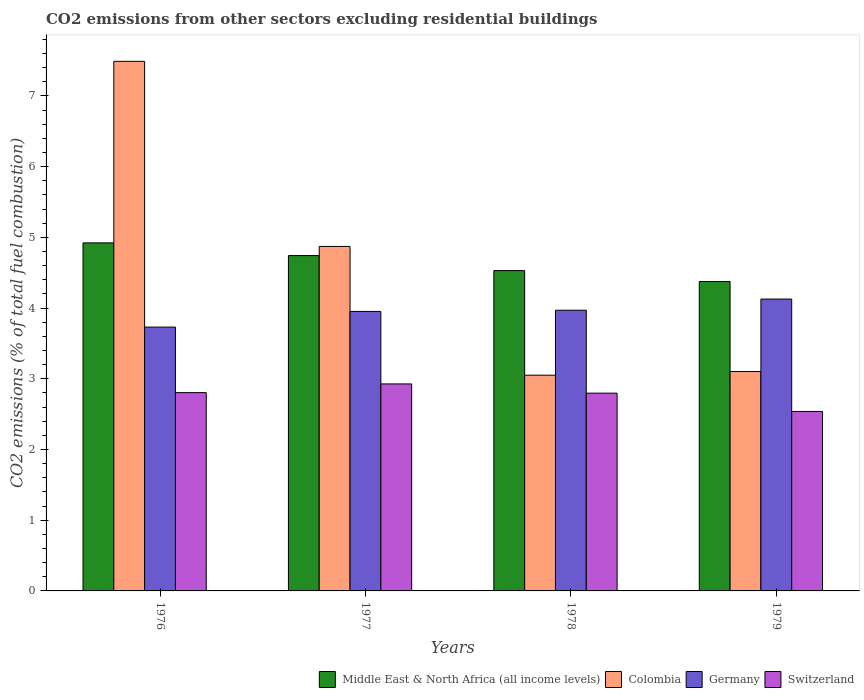How many different coloured bars are there?
Keep it short and to the point. 4. Are the number of bars on each tick of the X-axis equal?
Provide a succinct answer. Yes. How many bars are there on the 3rd tick from the right?
Offer a very short reply. 4. What is the label of the 3rd group of bars from the left?
Provide a succinct answer. 1978. In how many cases, is the number of bars for a given year not equal to the number of legend labels?
Offer a terse response. 0. What is the total CO2 emitted in Switzerland in 1978?
Your answer should be compact. 2.8. Across all years, what is the maximum total CO2 emitted in Middle East & North Africa (all income levels)?
Make the answer very short. 4.92. Across all years, what is the minimum total CO2 emitted in Switzerland?
Offer a terse response. 2.54. In which year was the total CO2 emitted in Colombia maximum?
Provide a succinct answer. 1976. In which year was the total CO2 emitted in Switzerland minimum?
Provide a succinct answer. 1979. What is the total total CO2 emitted in Colombia in the graph?
Ensure brevity in your answer.  18.52. What is the difference between the total CO2 emitted in Switzerland in 1976 and that in 1979?
Your response must be concise. 0.27. What is the difference between the total CO2 emitted in Colombia in 1976 and the total CO2 emitted in Germany in 1979?
Offer a terse response. 3.36. What is the average total CO2 emitted in Colombia per year?
Offer a terse response. 4.63. In the year 1979, what is the difference between the total CO2 emitted in Colombia and total CO2 emitted in Middle East & North Africa (all income levels)?
Keep it short and to the point. -1.27. What is the ratio of the total CO2 emitted in Germany in 1976 to that in 1979?
Your response must be concise. 0.9. Is the total CO2 emitted in Colombia in 1976 less than that in 1978?
Make the answer very short. No. What is the difference between the highest and the second highest total CO2 emitted in Germany?
Give a very brief answer. 0.16. What is the difference between the highest and the lowest total CO2 emitted in Colombia?
Your answer should be very brief. 4.44. In how many years, is the total CO2 emitted in Switzerland greater than the average total CO2 emitted in Switzerland taken over all years?
Provide a succinct answer. 3. Is the sum of the total CO2 emitted in Middle East & North Africa (all income levels) in 1977 and 1978 greater than the maximum total CO2 emitted in Colombia across all years?
Offer a terse response. Yes. What does the 2nd bar from the left in 1976 represents?
Your answer should be very brief. Colombia. What does the 1st bar from the right in 1976 represents?
Your response must be concise. Switzerland. Is it the case that in every year, the sum of the total CO2 emitted in Colombia and total CO2 emitted in Germany is greater than the total CO2 emitted in Middle East & North Africa (all income levels)?
Give a very brief answer. Yes. How many bars are there?
Offer a very short reply. 16. Are all the bars in the graph horizontal?
Offer a very short reply. No. How many years are there in the graph?
Give a very brief answer. 4. What is the difference between two consecutive major ticks on the Y-axis?
Your response must be concise. 1. Are the values on the major ticks of Y-axis written in scientific E-notation?
Your response must be concise. No. Where does the legend appear in the graph?
Make the answer very short. Bottom right. How many legend labels are there?
Make the answer very short. 4. What is the title of the graph?
Your answer should be compact. CO2 emissions from other sectors excluding residential buildings. What is the label or title of the Y-axis?
Make the answer very short. CO2 emissions (% of total fuel combustion). What is the CO2 emissions (% of total fuel combustion) in Middle East & North Africa (all income levels) in 1976?
Your answer should be very brief. 4.92. What is the CO2 emissions (% of total fuel combustion) of Colombia in 1976?
Keep it short and to the point. 7.49. What is the CO2 emissions (% of total fuel combustion) of Germany in 1976?
Your answer should be very brief. 3.73. What is the CO2 emissions (% of total fuel combustion) of Switzerland in 1976?
Provide a short and direct response. 2.8. What is the CO2 emissions (% of total fuel combustion) in Middle East & North Africa (all income levels) in 1977?
Your answer should be very brief. 4.74. What is the CO2 emissions (% of total fuel combustion) of Colombia in 1977?
Your answer should be very brief. 4.87. What is the CO2 emissions (% of total fuel combustion) in Germany in 1977?
Keep it short and to the point. 3.95. What is the CO2 emissions (% of total fuel combustion) in Switzerland in 1977?
Your response must be concise. 2.93. What is the CO2 emissions (% of total fuel combustion) in Middle East & North Africa (all income levels) in 1978?
Your answer should be compact. 4.53. What is the CO2 emissions (% of total fuel combustion) in Colombia in 1978?
Your response must be concise. 3.05. What is the CO2 emissions (% of total fuel combustion) in Germany in 1978?
Offer a very short reply. 3.97. What is the CO2 emissions (% of total fuel combustion) of Switzerland in 1978?
Keep it short and to the point. 2.8. What is the CO2 emissions (% of total fuel combustion) in Middle East & North Africa (all income levels) in 1979?
Make the answer very short. 4.38. What is the CO2 emissions (% of total fuel combustion) of Colombia in 1979?
Make the answer very short. 3.1. What is the CO2 emissions (% of total fuel combustion) of Germany in 1979?
Make the answer very short. 4.13. What is the CO2 emissions (% of total fuel combustion) in Switzerland in 1979?
Keep it short and to the point. 2.54. Across all years, what is the maximum CO2 emissions (% of total fuel combustion) in Middle East & North Africa (all income levels)?
Provide a short and direct response. 4.92. Across all years, what is the maximum CO2 emissions (% of total fuel combustion) of Colombia?
Your answer should be compact. 7.49. Across all years, what is the maximum CO2 emissions (% of total fuel combustion) of Germany?
Make the answer very short. 4.13. Across all years, what is the maximum CO2 emissions (% of total fuel combustion) in Switzerland?
Keep it short and to the point. 2.93. Across all years, what is the minimum CO2 emissions (% of total fuel combustion) of Middle East & North Africa (all income levels)?
Offer a very short reply. 4.38. Across all years, what is the minimum CO2 emissions (% of total fuel combustion) in Colombia?
Make the answer very short. 3.05. Across all years, what is the minimum CO2 emissions (% of total fuel combustion) of Germany?
Offer a very short reply. 3.73. Across all years, what is the minimum CO2 emissions (% of total fuel combustion) of Switzerland?
Make the answer very short. 2.54. What is the total CO2 emissions (% of total fuel combustion) in Middle East & North Africa (all income levels) in the graph?
Ensure brevity in your answer.  18.57. What is the total CO2 emissions (% of total fuel combustion) in Colombia in the graph?
Make the answer very short. 18.52. What is the total CO2 emissions (% of total fuel combustion) of Germany in the graph?
Ensure brevity in your answer.  15.78. What is the total CO2 emissions (% of total fuel combustion) in Switzerland in the graph?
Your answer should be very brief. 11.07. What is the difference between the CO2 emissions (% of total fuel combustion) in Middle East & North Africa (all income levels) in 1976 and that in 1977?
Offer a terse response. 0.18. What is the difference between the CO2 emissions (% of total fuel combustion) of Colombia in 1976 and that in 1977?
Ensure brevity in your answer.  2.62. What is the difference between the CO2 emissions (% of total fuel combustion) in Germany in 1976 and that in 1977?
Offer a terse response. -0.22. What is the difference between the CO2 emissions (% of total fuel combustion) of Switzerland in 1976 and that in 1977?
Your answer should be very brief. -0.12. What is the difference between the CO2 emissions (% of total fuel combustion) in Middle East & North Africa (all income levels) in 1976 and that in 1978?
Give a very brief answer. 0.39. What is the difference between the CO2 emissions (% of total fuel combustion) in Colombia in 1976 and that in 1978?
Your answer should be compact. 4.44. What is the difference between the CO2 emissions (% of total fuel combustion) in Germany in 1976 and that in 1978?
Offer a very short reply. -0.24. What is the difference between the CO2 emissions (% of total fuel combustion) in Switzerland in 1976 and that in 1978?
Keep it short and to the point. 0.01. What is the difference between the CO2 emissions (% of total fuel combustion) in Middle East & North Africa (all income levels) in 1976 and that in 1979?
Give a very brief answer. 0.55. What is the difference between the CO2 emissions (% of total fuel combustion) of Colombia in 1976 and that in 1979?
Offer a terse response. 4.39. What is the difference between the CO2 emissions (% of total fuel combustion) in Germany in 1976 and that in 1979?
Keep it short and to the point. -0.4. What is the difference between the CO2 emissions (% of total fuel combustion) in Switzerland in 1976 and that in 1979?
Make the answer very short. 0.27. What is the difference between the CO2 emissions (% of total fuel combustion) in Middle East & North Africa (all income levels) in 1977 and that in 1978?
Give a very brief answer. 0.21. What is the difference between the CO2 emissions (% of total fuel combustion) in Colombia in 1977 and that in 1978?
Make the answer very short. 1.82. What is the difference between the CO2 emissions (% of total fuel combustion) in Germany in 1977 and that in 1978?
Provide a succinct answer. -0.02. What is the difference between the CO2 emissions (% of total fuel combustion) in Switzerland in 1977 and that in 1978?
Make the answer very short. 0.13. What is the difference between the CO2 emissions (% of total fuel combustion) of Middle East & North Africa (all income levels) in 1977 and that in 1979?
Keep it short and to the point. 0.37. What is the difference between the CO2 emissions (% of total fuel combustion) in Colombia in 1977 and that in 1979?
Provide a short and direct response. 1.77. What is the difference between the CO2 emissions (% of total fuel combustion) of Germany in 1977 and that in 1979?
Make the answer very short. -0.17. What is the difference between the CO2 emissions (% of total fuel combustion) of Switzerland in 1977 and that in 1979?
Keep it short and to the point. 0.39. What is the difference between the CO2 emissions (% of total fuel combustion) of Middle East & North Africa (all income levels) in 1978 and that in 1979?
Keep it short and to the point. 0.15. What is the difference between the CO2 emissions (% of total fuel combustion) in Colombia in 1978 and that in 1979?
Provide a succinct answer. -0.05. What is the difference between the CO2 emissions (% of total fuel combustion) in Germany in 1978 and that in 1979?
Give a very brief answer. -0.16. What is the difference between the CO2 emissions (% of total fuel combustion) in Switzerland in 1978 and that in 1979?
Keep it short and to the point. 0.26. What is the difference between the CO2 emissions (% of total fuel combustion) in Middle East & North Africa (all income levels) in 1976 and the CO2 emissions (% of total fuel combustion) in Colombia in 1977?
Ensure brevity in your answer.  0.05. What is the difference between the CO2 emissions (% of total fuel combustion) of Middle East & North Africa (all income levels) in 1976 and the CO2 emissions (% of total fuel combustion) of Germany in 1977?
Give a very brief answer. 0.97. What is the difference between the CO2 emissions (% of total fuel combustion) of Middle East & North Africa (all income levels) in 1976 and the CO2 emissions (% of total fuel combustion) of Switzerland in 1977?
Your answer should be very brief. 2. What is the difference between the CO2 emissions (% of total fuel combustion) of Colombia in 1976 and the CO2 emissions (% of total fuel combustion) of Germany in 1977?
Ensure brevity in your answer.  3.54. What is the difference between the CO2 emissions (% of total fuel combustion) in Colombia in 1976 and the CO2 emissions (% of total fuel combustion) in Switzerland in 1977?
Offer a very short reply. 4.56. What is the difference between the CO2 emissions (% of total fuel combustion) in Germany in 1976 and the CO2 emissions (% of total fuel combustion) in Switzerland in 1977?
Provide a succinct answer. 0.8. What is the difference between the CO2 emissions (% of total fuel combustion) of Middle East & North Africa (all income levels) in 1976 and the CO2 emissions (% of total fuel combustion) of Colombia in 1978?
Your answer should be compact. 1.87. What is the difference between the CO2 emissions (% of total fuel combustion) in Middle East & North Africa (all income levels) in 1976 and the CO2 emissions (% of total fuel combustion) in Germany in 1978?
Offer a very short reply. 0.95. What is the difference between the CO2 emissions (% of total fuel combustion) in Middle East & North Africa (all income levels) in 1976 and the CO2 emissions (% of total fuel combustion) in Switzerland in 1978?
Your answer should be compact. 2.13. What is the difference between the CO2 emissions (% of total fuel combustion) in Colombia in 1976 and the CO2 emissions (% of total fuel combustion) in Germany in 1978?
Keep it short and to the point. 3.52. What is the difference between the CO2 emissions (% of total fuel combustion) of Colombia in 1976 and the CO2 emissions (% of total fuel combustion) of Switzerland in 1978?
Provide a succinct answer. 4.69. What is the difference between the CO2 emissions (% of total fuel combustion) in Germany in 1976 and the CO2 emissions (% of total fuel combustion) in Switzerland in 1978?
Provide a short and direct response. 0.93. What is the difference between the CO2 emissions (% of total fuel combustion) in Middle East & North Africa (all income levels) in 1976 and the CO2 emissions (% of total fuel combustion) in Colombia in 1979?
Ensure brevity in your answer.  1.82. What is the difference between the CO2 emissions (% of total fuel combustion) in Middle East & North Africa (all income levels) in 1976 and the CO2 emissions (% of total fuel combustion) in Germany in 1979?
Provide a succinct answer. 0.79. What is the difference between the CO2 emissions (% of total fuel combustion) in Middle East & North Africa (all income levels) in 1976 and the CO2 emissions (% of total fuel combustion) in Switzerland in 1979?
Provide a short and direct response. 2.38. What is the difference between the CO2 emissions (% of total fuel combustion) of Colombia in 1976 and the CO2 emissions (% of total fuel combustion) of Germany in 1979?
Your answer should be compact. 3.36. What is the difference between the CO2 emissions (% of total fuel combustion) in Colombia in 1976 and the CO2 emissions (% of total fuel combustion) in Switzerland in 1979?
Your answer should be very brief. 4.95. What is the difference between the CO2 emissions (% of total fuel combustion) in Germany in 1976 and the CO2 emissions (% of total fuel combustion) in Switzerland in 1979?
Give a very brief answer. 1.19. What is the difference between the CO2 emissions (% of total fuel combustion) in Middle East & North Africa (all income levels) in 1977 and the CO2 emissions (% of total fuel combustion) in Colombia in 1978?
Offer a very short reply. 1.69. What is the difference between the CO2 emissions (% of total fuel combustion) in Middle East & North Africa (all income levels) in 1977 and the CO2 emissions (% of total fuel combustion) in Germany in 1978?
Your answer should be compact. 0.77. What is the difference between the CO2 emissions (% of total fuel combustion) of Middle East & North Africa (all income levels) in 1977 and the CO2 emissions (% of total fuel combustion) of Switzerland in 1978?
Keep it short and to the point. 1.95. What is the difference between the CO2 emissions (% of total fuel combustion) of Colombia in 1977 and the CO2 emissions (% of total fuel combustion) of Germany in 1978?
Your answer should be compact. 0.9. What is the difference between the CO2 emissions (% of total fuel combustion) in Colombia in 1977 and the CO2 emissions (% of total fuel combustion) in Switzerland in 1978?
Your response must be concise. 2.08. What is the difference between the CO2 emissions (% of total fuel combustion) in Germany in 1977 and the CO2 emissions (% of total fuel combustion) in Switzerland in 1978?
Your response must be concise. 1.16. What is the difference between the CO2 emissions (% of total fuel combustion) of Middle East & North Africa (all income levels) in 1977 and the CO2 emissions (% of total fuel combustion) of Colombia in 1979?
Make the answer very short. 1.64. What is the difference between the CO2 emissions (% of total fuel combustion) of Middle East & North Africa (all income levels) in 1977 and the CO2 emissions (% of total fuel combustion) of Germany in 1979?
Ensure brevity in your answer.  0.61. What is the difference between the CO2 emissions (% of total fuel combustion) of Middle East & North Africa (all income levels) in 1977 and the CO2 emissions (% of total fuel combustion) of Switzerland in 1979?
Keep it short and to the point. 2.2. What is the difference between the CO2 emissions (% of total fuel combustion) in Colombia in 1977 and the CO2 emissions (% of total fuel combustion) in Germany in 1979?
Make the answer very short. 0.74. What is the difference between the CO2 emissions (% of total fuel combustion) of Colombia in 1977 and the CO2 emissions (% of total fuel combustion) of Switzerland in 1979?
Provide a short and direct response. 2.33. What is the difference between the CO2 emissions (% of total fuel combustion) in Germany in 1977 and the CO2 emissions (% of total fuel combustion) in Switzerland in 1979?
Your answer should be compact. 1.41. What is the difference between the CO2 emissions (% of total fuel combustion) in Middle East & North Africa (all income levels) in 1978 and the CO2 emissions (% of total fuel combustion) in Colombia in 1979?
Your answer should be compact. 1.43. What is the difference between the CO2 emissions (% of total fuel combustion) of Middle East & North Africa (all income levels) in 1978 and the CO2 emissions (% of total fuel combustion) of Germany in 1979?
Your response must be concise. 0.4. What is the difference between the CO2 emissions (% of total fuel combustion) of Middle East & North Africa (all income levels) in 1978 and the CO2 emissions (% of total fuel combustion) of Switzerland in 1979?
Keep it short and to the point. 1.99. What is the difference between the CO2 emissions (% of total fuel combustion) in Colombia in 1978 and the CO2 emissions (% of total fuel combustion) in Germany in 1979?
Offer a very short reply. -1.08. What is the difference between the CO2 emissions (% of total fuel combustion) in Colombia in 1978 and the CO2 emissions (% of total fuel combustion) in Switzerland in 1979?
Offer a very short reply. 0.51. What is the difference between the CO2 emissions (% of total fuel combustion) in Germany in 1978 and the CO2 emissions (% of total fuel combustion) in Switzerland in 1979?
Your answer should be very brief. 1.43. What is the average CO2 emissions (% of total fuel combustion) in Middle East & North Africa (all income levels) per year?
Offer a terse response. 4.64. What is the average CO2 emissions (% of total fuel combustion) of Colombia per year?
Provide a short and direct response. 4.63. What is the average CO2 emissions (% of total fuel combustion) of Germany per year?
Give a very brief answer. 3.95. What is the average CO2 emissions (% of total fuel combustion) of Switzerland per year?
Offer a very short reply. 2.77. In the year 1976, what is the difference between the CO2 emissions (% of total fuel combustion) of Middle East & North Africa (all income levels) and CO2 emissions (% of total fuel combustion) of Colombia?
Your response must be concise. -2.57. In the year 1976, what is the difference between the CO2 emissions (% of total fuel combustion) of Middle East & North Africa (all income levels) and CO2 emissions (% of total fuel combustion) of Germany?
Your answer should be compact. 1.19. In the year 1976, what is the difference between the CO2 emissions (% of total fuel combustion) of Middle East & North Africa (all income levels) and CO2 emissions (% of total fuel combustion) of Switzerland?
Offer a very short reply. 2.12. In the year 1976, what is the difference between the CO2 emissions (% of total fuel combustion) of Colombia and CO2 emissions (% of total fuel combustion) of Germany?
Your response must be concise. 3.76. In the year 1976, what is the difference between the CO2 emissions (% of total fuel combustion) in Colombia and CO2 emissions (% of total fuel combustion) in Switzerland?
Offer a terse response. 4.69. In the year 1976, what is the difference between the CO2 emissions (% of total fuel combustion) of Germany and CO2 emissions (% of total fuel combustion) of Switzerland?
Provide a succinct answer. 0.93. In the year 1977, what is the difference between the CO2 emissions (% of total fuel combustion) in Middle East & North Africa (all income levels) and CO2 emissions (% of total fuel combustion) in Colombia?
Keep it short and to the point. -0.13. In the year 1977, what is the difference between the CO2 emissions (% of total fuel combustion) in Middle East & North Africa (all income levels) and CO2 emissions (% of total fuel combustion) in Germany?
Your response must be concise. 0.79. In the year 1977, what is the difference between the CO2 emissions (% of total fuel combustion) of Middle East & North Africa (all income levels) and CO2 emissions (% of total fuel combustion) of Switzerland?
Ensure brevity in your answer.  1.82. In the year 1977, what is the difference between the CO2 emissions (% of total fuel combustion) of Colombia and CO2 emissions (% of total fuel combustion) of Germany?
Provide a succinct answer. 0.92. In the year 1977, what is the difference between the CO2 emissions (% of total fuel combustion) in Colombia and CO2 emissions (% of total fuel combustion) in Switzerland?
Your response must be concise. 1.95. In the year 1977, what is the difference between the CO2 emissions (% of total fuel combustion) in Germany and CO2 emissions (% of total fuel combustion) in Switzerland?
Provide a short and direct response. 1.03. In the year 1978, what is the difference between the CO2 emissions (% of total fuel combustion) of Middle East & North Africa (all income levels) and CO2 emissions (% of total fuel combustion) of Colombia?
Offer a terse response. 1.48. In the year 1978, what is the difference between the CO2 emissions (% of total fuel combustion) of Middle East & North Africa (all income levels) and CO2 emissions (% of total fuel combustion) of Germany?
Ensure brevity in your answer.  0.56. In the year 1978, what is the difference between the CO2 emissions (% of total fuel combustion) in Middle East & North Africa (all income levels) and CO2 emissions (% of total fuel combustion) in Switzerland?
Your response must be concise. 1.73. In the year 1978, what is the difference between the CO2 emissions (% of total fuel combustion) in Colombia and CO2 emissions (% of total fuel combustion) in Germany?
Give a very brief answer. -0.92. In the year 1978, what is the difference between the CO2 emissions (% of total fuel combustion) in Colombia and CO2 emissions (% of total fuel combustion) in Switzerland?
Your response must be concise. 0.25. In the year 1978, what is the difference between the CO2 emissions (% of total fuel combustion) in Germany and CO2 emissions (% of total fuel combustion) in Switzerland?
Make the answer very short. 1.17. In the year 1979, what is the difference between the CO2 emissions (% of total fuel combustion) in Middle East & North Africa (all income levels) and CO2 emissions (% of total fuel combustion) in Colombia?
Provide a short and direct response. 1.27. In the year 1979, what is the difference between the CO2 emissions (% of total fuel combustion) in Middle East & North Africa (all income levels) and CO2 emissions (% of total fuel combustion) in Germany?
Give a very brief answer. 0.25. In the year 1979, what is the difference between the CO2 emissions (% of total fuel combustion) of Middle East & North Africa (all income levels) and CO2 emissions (% of total fuel combustion) of Switzerland?
Offer a very short reply. 1.84. In the year 1979, what is the difference between the CO2 emissions (% of total fuel combustion) in Colombia and CO2 emissions (% of total fuel combustion) in Germany?
Your answer should be very brief. -1.03. In the year 1979, what is the difference between the CO2 emissions (% of total fuel combustion) of Colombia and CO2 emissions (% of total fuel combustion) of Switzerland?
Your response must be concise. 0.56. In the year 1979, what is the difference between the CO2 emissions (% of total fuel combustion) of Germany and CO2 emissions (% of total fuel combustion) of Switzerland?
Your response must be concise. 1.59. What is the ratio of the CO2 emissions (% of total fuel combustion) of Middle East & North Africa (all income levels) in 1976 to that in 1977?
Provide a short and direct response. 1.04. What is the ratio of the CO2 emissions (% of total fuel combustion) of Colombia in 1976 to that in 1977?
Keep it short and to the point. 1.54. What is the ratio of the CO2 emissions (% of total fuel combustion) in Germany in 1976 to that in 1977?
Provide a succinct answer. 0.94. What is the ratio of the CO2 emissions (% of total fuel combustion) of Switzerland in 1976 to that in 1977?
Offer a terse response. 0.96. What is the ratio of the CO2 emissions (% of total fuel combustion) in Middle East & North Africa (all income levels) in 1976 to that in 1978?
Your response must be concise. 1.09. What is the ratio of the CO2 emissions (% of total fuel combustion) of Colombia in 1976 to that in 1978?
Provide a short and direct response. 2.45. What is the ratio of the CO2 emissions (% of total fuel combustion) of Germany in 1976 to that in 1978?
Offer a very short reply. 0.94. What is the ratio of the CO2 emissions (% of total fuel combustion) in Switzerland in 1976 to that in 1978?
Provide a succinct answer. 1. What is the ratio of the CO2 emissions (% of total fuel combustion) of Middle East & North Africa (all income levels) in 1976 to that in 1979?
Offer a very short reply. 1.12. What is the ratio of the CO2 emissions (% of total fuel combustion) of Colombia in 1976 to that in 1979?
Make the answer very short. 2.41. What is the ratio of the CO2 emissions (% of total fuel combustion) of Germany in 1976 to that in 1979?
Provide a succinct answer. 0.9. What is the ratio of the CO2 emissions (% of total fuel combustion) of Switzerland in 1976 to that in 1979?
Your answer should be very brief. 1.1. What is the ratio of the CO2 emissions (% of total fuel combustion) of Middle East & North Africa (all income levels) in 1977 to that in 1978?
Give a very brief answer. 1.05. What is the ratio of the CO2 emissions (% of total fuel combustion) of Colombia in 1977 to that in 1978?
Give a very brief answer. 1.6. What is the ratio of the CO2 emissions (% of total fuel combustion) of Germany in 1977 to that in 1978?
Provide a succinct answer. 1. What is the ratio of the CO2 emissions (% of total fuel combustion) in Switzerland in 1977 to that in 1978?
Ensure brevity in your answer.  1.05. What is the ratio of the CO2 emissions (% of total fuel combustion) of Middle East & North Africa (all income levels) in 1977 to that in 1979?
Your answer should be compact. 1.08. What is the ratio of the CO2 emissions (% of total fuel combustion) in Colombia in 1977 to that in 1979?
Make the answer very short. 1.57. What is the ratio of the CO2 emissions (% of total fuel combustion) in Germany in 1977 to that in 1979?
Provide a short and direct response. 0.96. What is the ratio of the CO2 emissions (% of total fuel combustion) in Switzerland in 1977 to that in 1979?
Offer a terse response. 1.15. What is the ratio of the CO2 emissions (% of total fuel combustion) of Middle East & North Africa (all income levels) in 1978 to that in 1979?
Your response must be concise. 1.04. What is the ratio of the CO2 emissions (% of total fuel combustion) of Colombia in 1978 to that in 1979?
Your answer should be compact. 0.98. What is the ratio of the CO2 emissions (% of total fuel combustion) in Germany in 1978 to that in 1979?
Your answer should be compact. 0.96. What is the ratio of the CO2 emissions (% of total fuel combustion) in Switzerland in 1978 to that in 1979?
Provide a succinct answer. 1.1. What is the difference between the highest and the second highest CO2 emissions (% of total fuel combustion) of Middle East & North Africa (all income levels)?
Offer a terse response. 0.18. What is the difference between the highest and the second highest CO2 emissions (% of total fuel combustion) of Colombia?
Keep it short and to the point. 2.62. What is the difference between the highest and the second highest CO2 emissions (% of total fuel combustion) of Germany?
Offer a very short reply. 0.16. What is the difference between the highest and the second highest CO2 emissions (% of total fuel combustion) in Switzerland?
Give a very brief answer. 0.12. What is the difference between the highest and the lowest CO2 emissions (% of total fuel combustion) of Middle East & North Africa (all income levels)?
Offer a very short reply. 0.55. What is the difference between the highest and the lowest CO2 emissions (% of total fuel combustion) in Colombia?
Make the answer very short. 4.44. What is the difference between the highest and the lowest CO2 emissions (% of total fuel combustion) of Germany?
Make the answer very short. 0.4. What is the difference between the highest and the lowest CO2 emissions (% of total fuel combustion) of Switzerland?
Offer a very short reply. 0.39. 